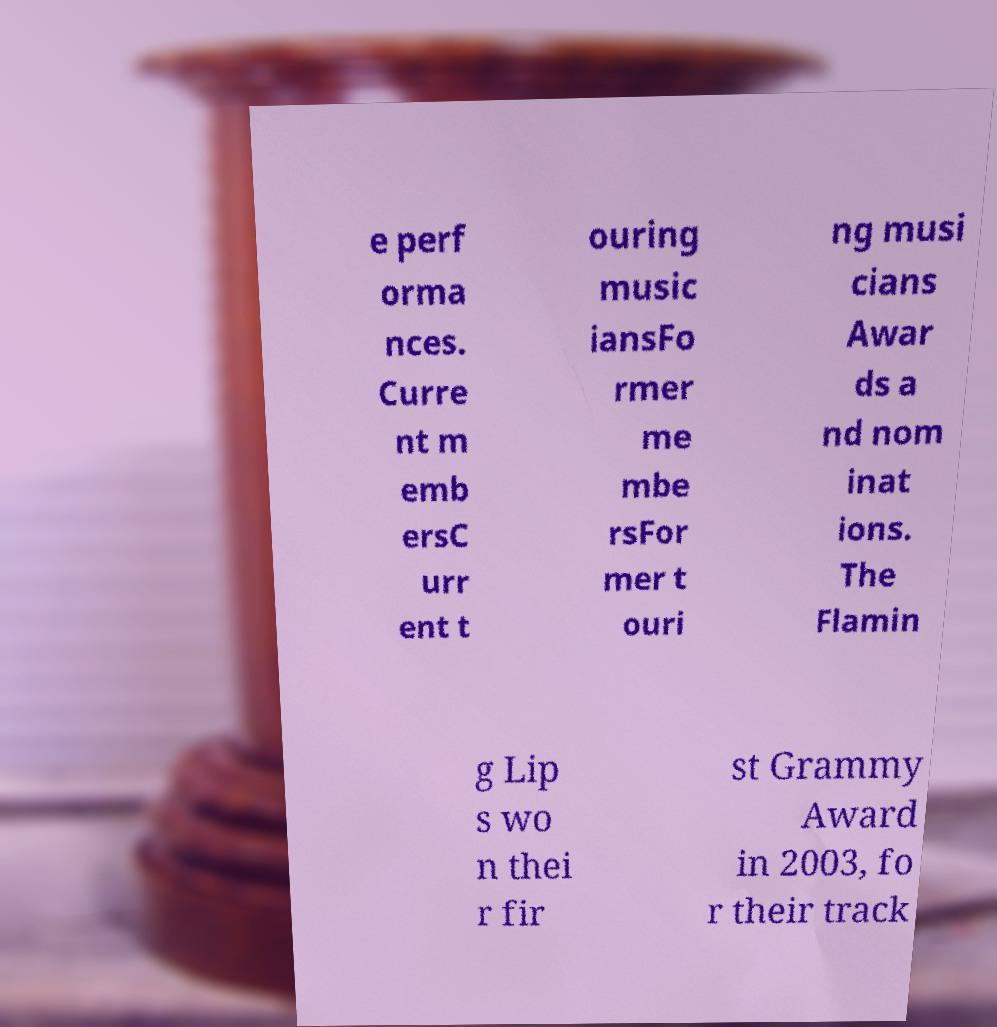Please read and relay the text visible in this image. What does it say? e perf orma nces. Curre nt m emb ersC urr ent t ouring music iansFo rmer me mbe rsFor mer t ouri ng musi cians Awar ds a nd nom inat ions. The Flamin g Lip s wo n thei r fir st Grammy Award in 2003, fo r their track 